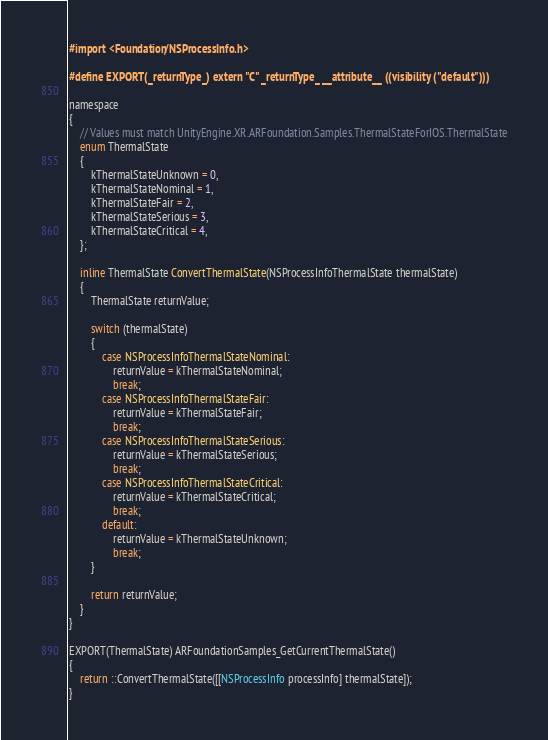<code> <loc_0><loc_0><loc_500><loc_500><_ObjectiveC_>#import <Foundation/NSProcessInfo.h>

#define EXPORT(_returnType_) extern "C" _returnType_ __attribute__ ((visibility ("default")))

namespace
{
    // Values must match UnityEngine.XR.ARFoundation.Samples.ThermalStateForIOS.ThermalState
    enum ThermalState
    {
        kThermalStateUnknown = 0,
        kThermalStateNominal = 1,
        kThermalStateFair = 2,
        kThermalStateSerious = 3,
        kThermalStateCritical = 4,
    };

    inline ThermalState ConvertThermalState(NSProcessInfoThermalState thermalState)
    {
        ThermalState returnValue;

        switch (thermalState)
        {
            case NSProcessInfoThermalStateNominal:
                returnValue = kThermalStateNominal;
                break;
            case NSProcessInfoThermalStateFair:
                returnValue = kThermalStateFair;
                break;
            case NSProcessInfoThermalStateSerious:
                returnValue = kThermalStateSerious;
                break;
            case NSProcessInfoThermalStateCritical:
                returnValue = kThermalStateCritical;
                break;
            default:
                returnValue = kThermalStateUnknown;
                break;
        }

        return returnValue;
    }
}

EXPORT(ThermalState) ARFoundationSamples_GetCurrentThermalState()
{
    return ::ConvertThermalState([[NSProcessInfo processInfo] thermalState]);
}
</code> 